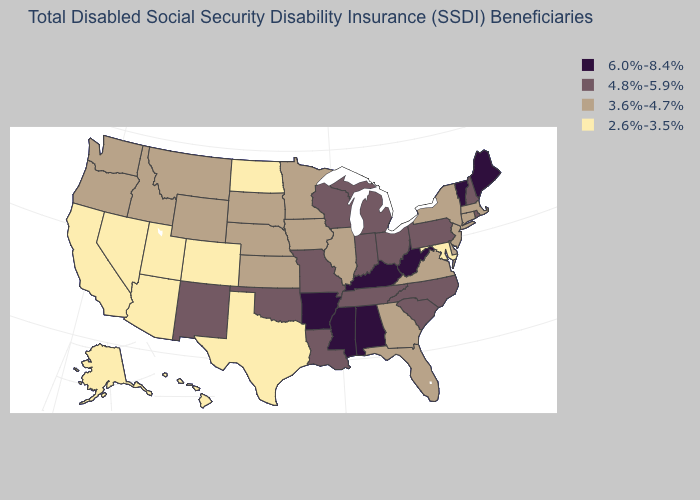What is the highest value in states that border Maryland?
Quick response, please. 6.0%-8.4%. Name the states that have a value in the range 2.6%-3.5%?
Be succinct. Alaska, Arizona, California, Colorado, Hawaii, Maryland, Nevada, North Dakota, Texas, Utah. What is the value of Oregon?
Concise answer only. 3.6%-4.7%. Does the map have missing data?
Quick response, please. No. Name the states that have a value in the range 3.6%-4.7%?
Short answer required. Connecticut, Delaware, Florida, Georgia, Idaho, Illinois, Iowa, Kansas, Massachusetts, Minnesota, Montana, Nebraska, New Jersey, New York, Oregon, South Dakota, Virginia, Washington, Wyoming. Name the states that have a value in the range 3.6%-4.7%?
Answer briefly. Connecticut, Delaware, Florida, Georgia, Idaho, Illinois, Iowa, Kansas, Massachusetts, Minnesota, Montana, Nebraska, New Jersey, New York, Oregon, South Dakota, Virginia, Washington, Wyoming. Among the states that border Alabama , which have the lowest value?
Concise answer only. Florida, Georgia. Name the states that have a value in the range 2.6%-3.5%?
Quick response, please. Alaska, Arizona, California, Colorado, Hawaii, Maryland, Nevada, North Dakota, Texas, Utah. Name the states that have a value in the range 4.8%-5.9%?
Keep it brief. Indiana, Louisiana, Michigan, Missouri, New Hampshire, New Mexico, North Carolina, Ohio, Oklahoma, Pennsylvania, Rhode Island, South Carolina, Tennessee, Wisconsin. Does Montana have a higher value than Texas?
Concise answer only. Yes. Name the states that have a value in the range 3.6%-4.7%?
Keep it brief. Connecticut, Delaware, Florida, Georgia, Idaho, Illinois, Iowa, Kansas, Massachusetts, Minnesota, Montana, Nebraska, New Jersey, New York, Oregon, South Dakota, Virginia, Washington, Wyoming. What is the value of Maryland?
Be succinct. 2.6%-3.5%. Does the first symbol in the legend represent the smallest category?
Short answer required. No. Among the states that border Minnesota , which have the highest value?
Be succinct. Wisconsin. What is the highest value in states that border Washington?
Give a very brief answer. 3.6%-4.7%. 